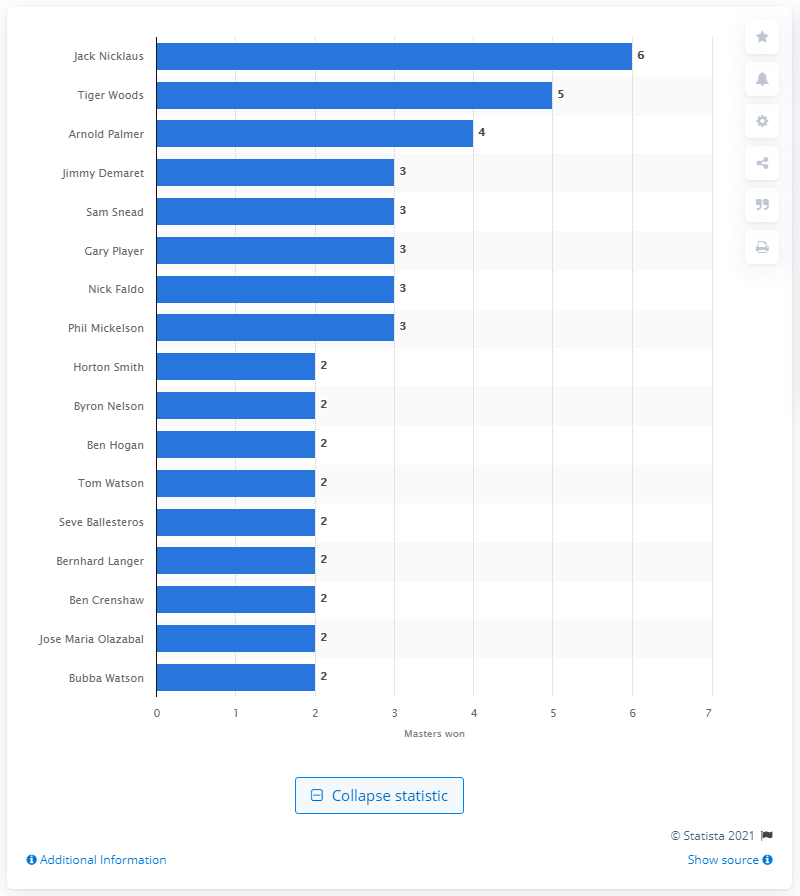Specify some key components in this picture. Tiger Woods has achieved an extraordinary milestone by winning the Masters Tournament five times, an achievement that only a select few have ever accomplished. 